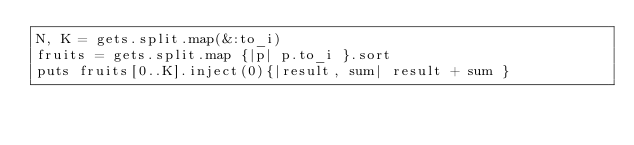Convert code to text. <code><loc_0><loc_0><loc_500><loc_500><_Ruby_>N, K = gets.split.map(&:to_i)
fruits = gets.split.map {|p| p.to_i }.sort
puts fruits[0..K].inject(0){|result, sum| result + sum }</code> 